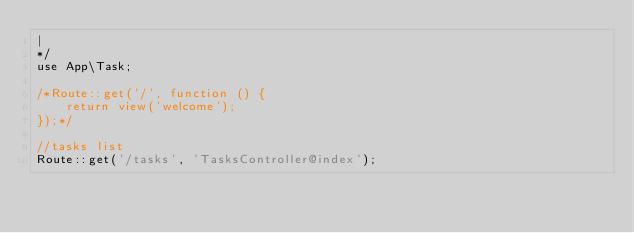<code> <loc_0><loc_0><loc_500><loc_500><_PHP_>|
*/
use App\Task;

/*Route::get('/', function () {
    return view('welcome');
});*/

//tasks list
Route::get('/tasks', 'TasksController@index');
</code> 